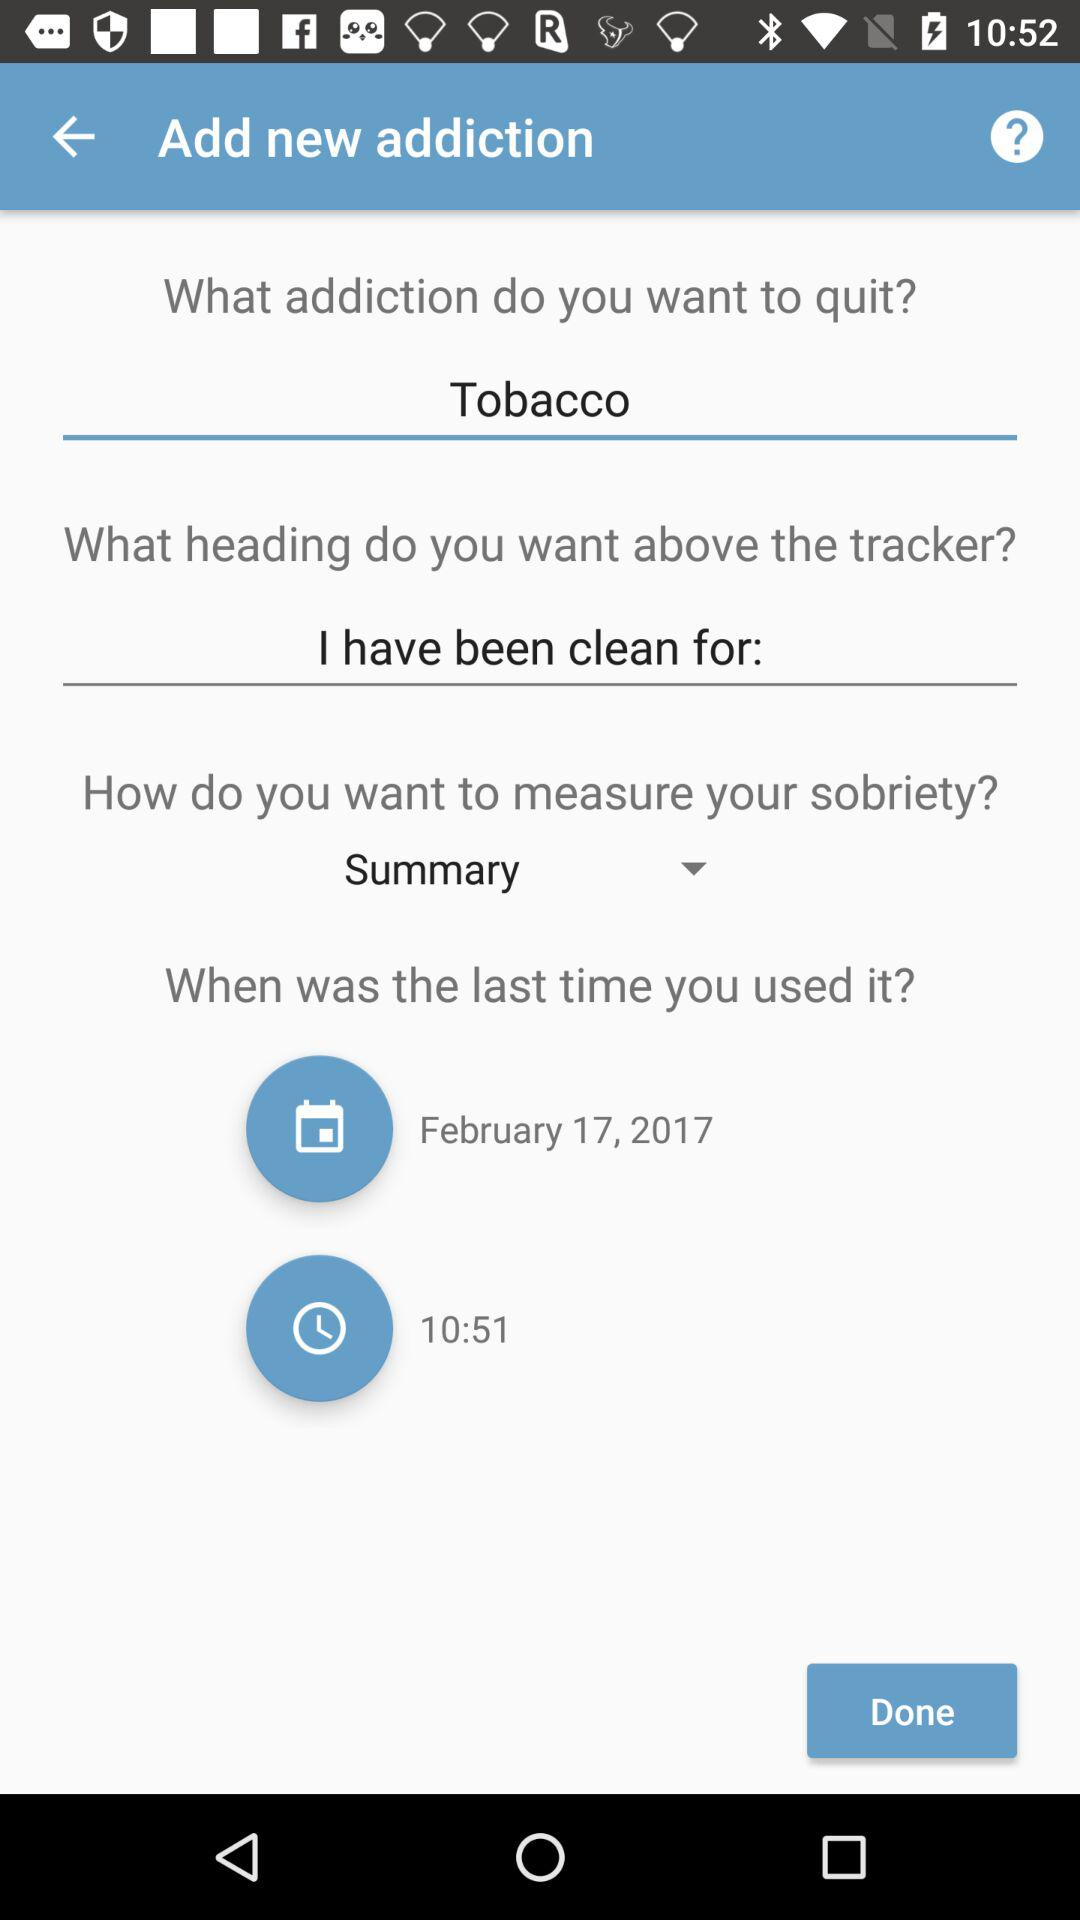What is the time? The time is 10:51. 